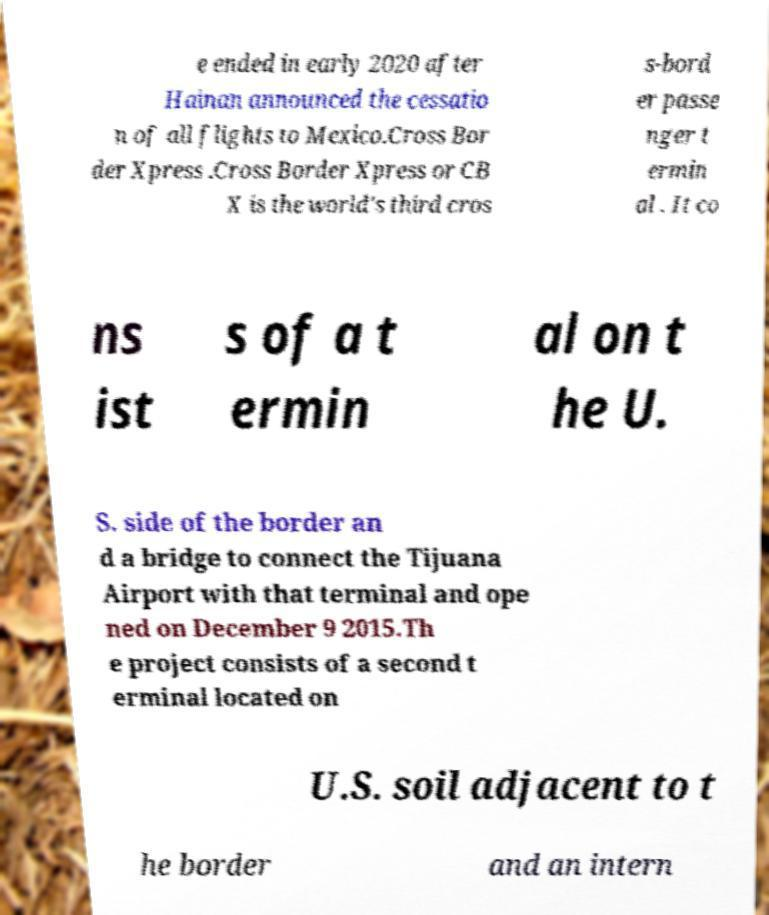Can you accurately transcribe the text from the provided image for me? e ended in early 2020 after Hainan announced the cessatio n of all flights to Mexico.Cross Bor der Xpress .Cross Border Xpress or CB X is the world's third cros s-bord er passe nger t ermin al . It co ns ist s of a t ermin al on t he U. S. side of the border an d a bridge to connect the Tijuana Airport with that terminal and ope ned on December 9 2015.Th e project consists of a second t erminal located on U.S. soil adjacent to t he border and an intern 